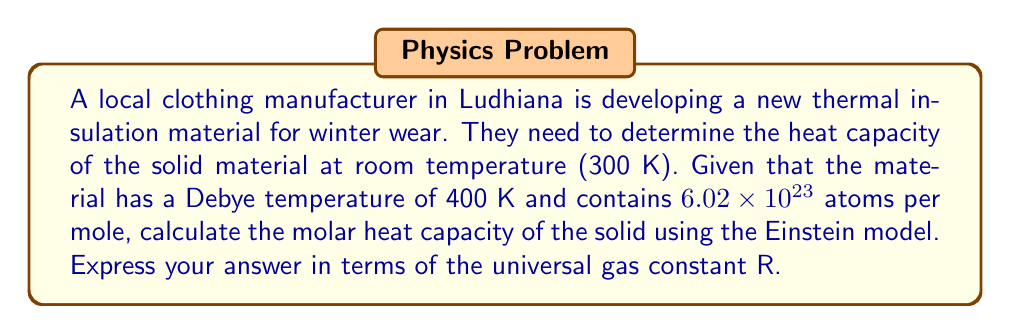Teach me how to tackle this problem. To solve this problem using the Einstein model, we'll follow these steps:

1) The Einstein model for the molar heat capacity of a solid is given by:

   $$C_V = 3R \left(\frac{\theta_E}{T}\right)^2 \frac{e^{\theta_E/T}}{(e^{\theta_E/T}-1)^2}$$

   where R is the universal gas constant, $\theta_E$ is the Einstein temperature, and T is the temperature of the solid.

2) We're given the Debye temperature, but we need the Einstein temperature. For many solids, the Einstein temperature is approximately equal to $0.75\theta_D$, where $\theta_D$ is the Debye temperature. So:

   $$\theta_E \approx 0.75 \times 400 \text{ K} = 300 \text{ K}$$

3) Now we can substitute the values into the Einstein model equation:
   
   T = 300 K
   $\theta_E$ = 300 K

   $$C_V = 3R \left(\frac{300}{300}\right)^2 \frac{e^{300/300}}{(e^{300/300}-1)^2}$$

4) Simplify:
   
   $$C_V = 3R \cdot 1^2 \cdot \frac{e^1}{(e^1-1)^2}$$

5) Calculate:
   
   $$C_V = 3R \cdot \frac{2.718}{(1.718)^2} \approx 2.78R$$
Answer: $2.78R$ 